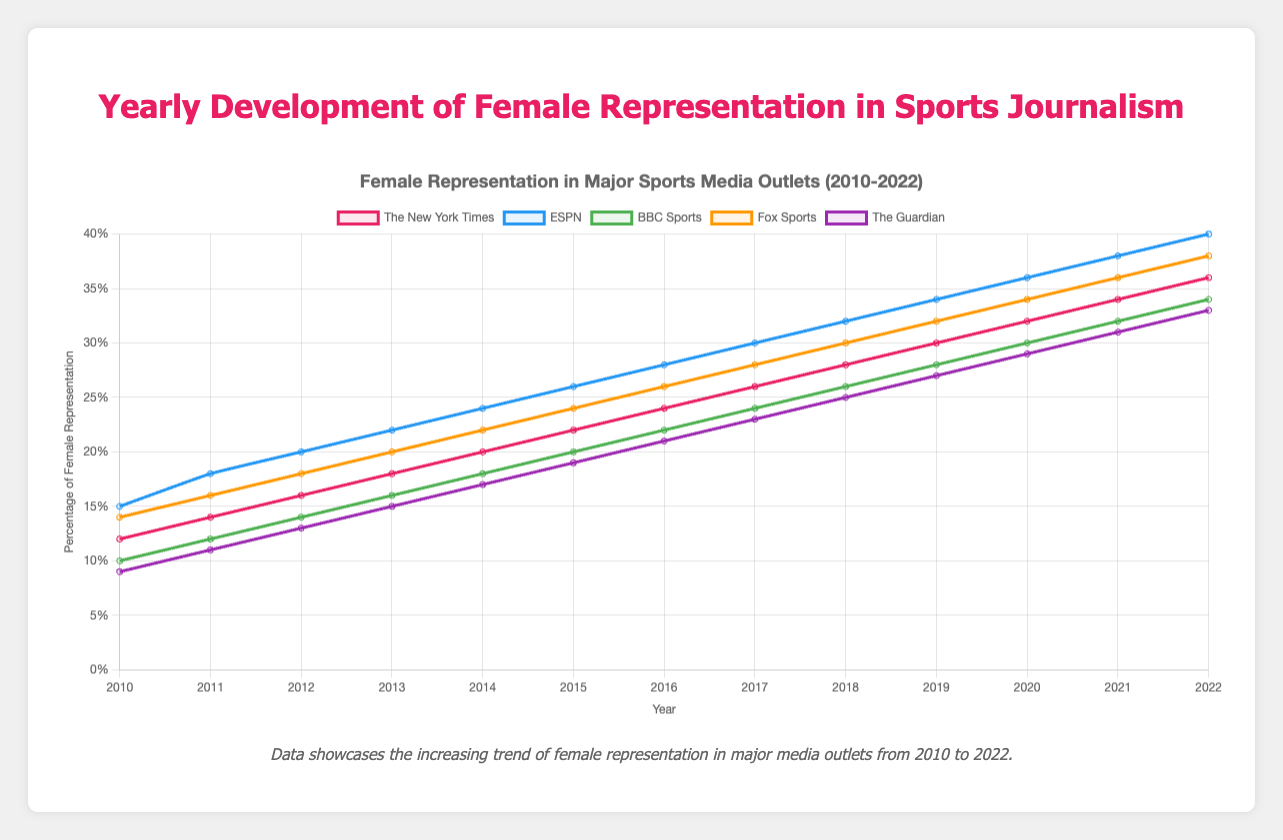What's the percentage increase in female representation at The New York Times from 2010 to 2022? In 2010, the percentage was 12%, and in 2022, it is 36%. The increase is 36% - 12% = 24%.
Answer: 24% Which media outlet had the highest percentage of female representation in 2022? Based on the chart, ESPN had the highest percentage at 40%.
Answer: ESPN Did Fox Sports ever have higher female representation than ESPN between 2010 and 2022? The chart shows that ESPN consistently had a higher percentage of female representation than Fox Sports from 2010 to 2022.
Answer: No What is the average female representation at BBC Sports between 2010 and 2015? The percentages are 10%, 12%, 14%, 16%, 18%, and 20%. The average is (10 + 12 + 14 + 16 + 18 + 20) / 6 = 15%.
Answer: 15% In which year did The Guardian reach a female representation of 25%? By examining the chart, The Guardian reached 25% in 2018.
Answer: 2018 By how much did female representation increase at ESPN from 2010 to 2015? In 2010, ESPN had 15%, and in 2015, it had 26%. The increase is 26% - 15% = 11%.
Answer: 11% Which year did The New York Times first surpass a female representation of 20%? According to the chart, The New York Times first surpassed 20% in 2014 with exactly 20%.
Answer: 2014 Who had a larger increase in female representation from 2016 to 2022, BBC Sports or Fox Sports? BBC Sports increased from 22% to 34% (12% increase), while Fox Sports went from 26% to 38% (12% increase). Both had the same increase of 12%.
Answer: Both the same Which media outlet had the smallest initial percentage of female representation in 2010? The chart indicates that The Guardian had the smallest initial percentage at 9%.
Answer: The Guardian 